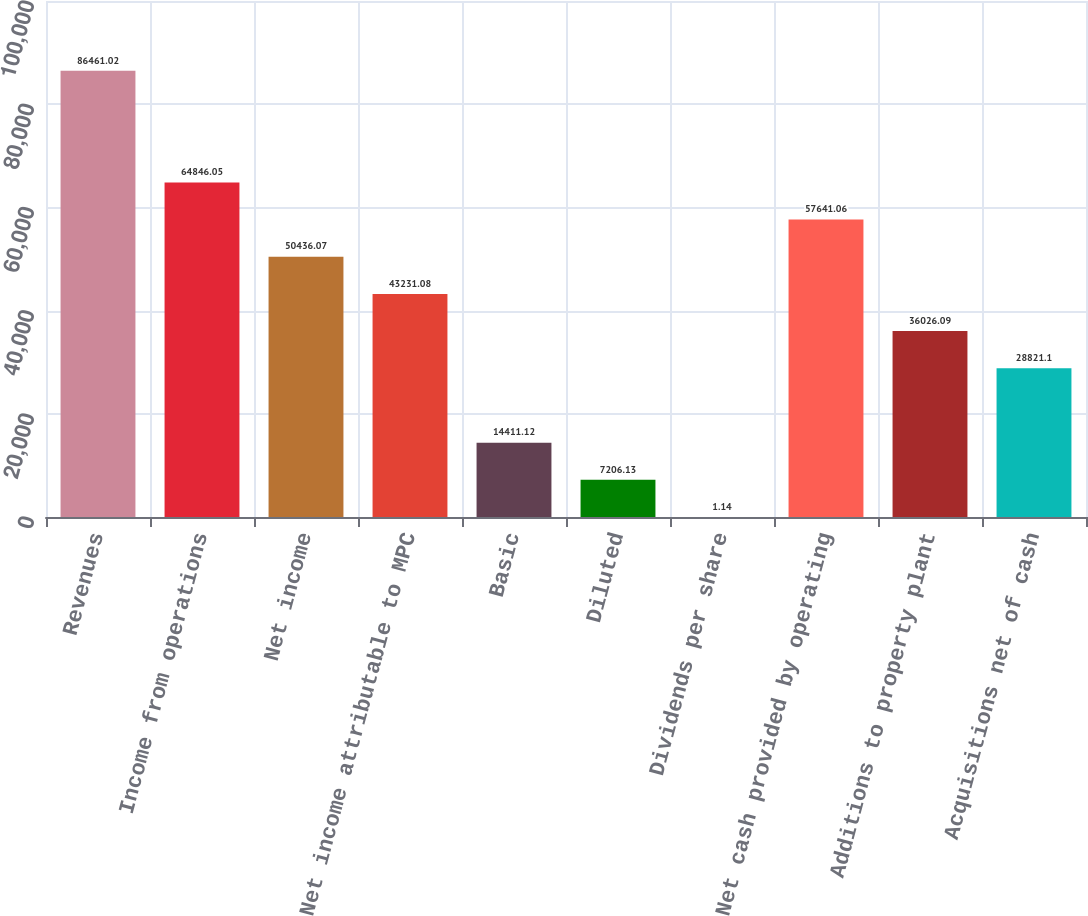Convert chart to OTSL. <chart><loc_0><loc_0><loc_500><loc_500><bar_chart><fcel>Revenues<fcel>Income from operations<fcel>Net income<fcel>Net income attributable to MPC<fcel>Basic<fcel>Diluted<fcel>Dividends per share<fcel>Net cash provided by operating<fcel>Additions to property plant<fcel>Acquisitions net of cash<nl><fcel>86461<fcel>64846.1<fcel>50436.1<fcel>43231.1<fcel>14411.1<fcel>7206.13<fcel>1.14<fcel>57641.1<fcel>36026.1<fcel>28821.1<nl></chart> 